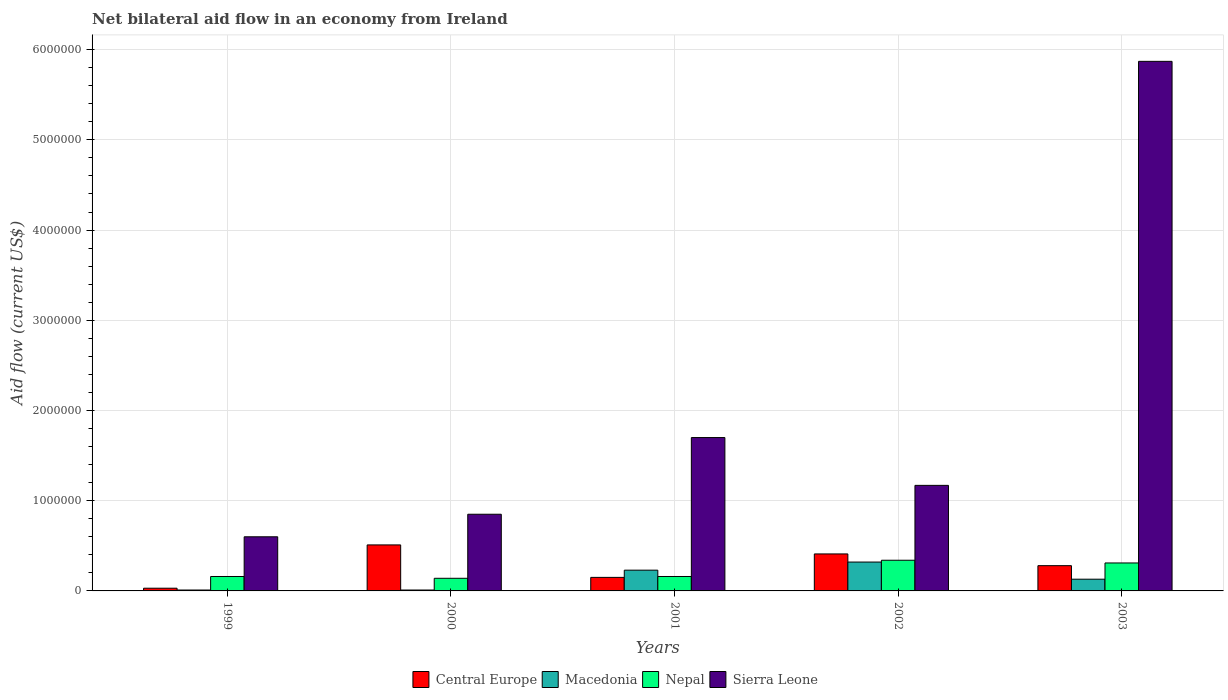How many different coloured bars are there?
Keep it short and to the point. 4. How many groups of bars are there?
Make the answer very short. 5. Are the number of bars per tick equal to the number of legend labels?
Your response must be concise. Yes. How many bars are there on the 1st tick from the left?
Give a very brief answer. 4. What is the label of the 4th group of bars from the left?
Offer a very short reply. 2002. What is the net bilateral aid flow in Central Europe in 1999?
Your answer should be very brief. 3.00e+04. Across all years, what is the maximum net bilateral aid flow in Macedonia?
Your answer should be compact. 3.20e+05. Across all years, what is the minimum net bilateral aid flow in Macedonia?
Your response must be concise. 10000. What is the total net bilateral aid flow in Sierra Leone in the graph?
Provide a succinct answer. 1.02e+07. What is the difference between the net bilateral aid flow in Sierra Leone in 2000 and the net bilateral aid flow in Macedonia in 1999?
Provide a short and direct response. 8.40e+05. What is the average net bilateral aid flow in Sierra Leone per year?
Give a very brief answer. 2.04e+06. In the year 1999, what is the difference between the net bilateral aid flow in Central Europe and net bilateral aid flow in Nepal?
Give a very brief answer. -1.30e+05. In how many years, is the net bilateral aid flow in Sierra Leone greater than 400000 US$?
Your response must be concise. 5. What is the ratio of the net bilateral aid flow in Central Europe in 2002 to that in 2003?
Your answer should be very brief. 1.46. What is the difference between the highest and the lowest net bilateral aid flow in Central Europe?
Your answer should be compact. 4.80e+05. Is the sum of the net bilateral aid flow in Macedonia in 2000 and 2002 greater than the maximum net bilateral aid flow in Central Europe across all years?
Offer a very short reply. No. What does the 4th bar from the left in 2000 represents?
Provide a short and direct response. Sierra Leone. What does the 1st bar from the right in 2001 represents?
Offer a terse response. Sierra Leone. How many bars are there?
Keep it short and to the point. 20. Are all the bars in the graph horizontal?
Your answer should be very brief. No. What is the difference between two consecutive major ticks on the Y-axis?
Your answer should be very brief. 1.00e+06. Does the graph contain any zero values?
Make the answer very short. No. Does the graph contain grids?
Keep it short and to the point. Yes. How many legend labels are there?
Provide a succinct answer. 4. How are the legend labels stacked?
Your answer should be very brief. Horizontal. What is the title of the graph?
Your answer should be compact. Net bilateral aid flow in an economy from Ireland. What is the Aid flow (current US$) in Macedonia in 1999?
Make the answer very short. 10000. What is the Aid flow (current US$) of Nepal in 1999?
Give a very brief answer. 1.60e+05. What is the Aid flow (current US$) of Sierra Leone in 1999?
Offer a terse response. 6.00e+05. What is the Aid flow (current US$) in Central Europe in 2000?
Offer a terse response. 5.10e+05. What is the Aid flow (current US$) of Nepal in 2000?
Your response must be concise. 1.40e+05. What is the Aid flow (current US$) in Sierra Leone in 2000?
Offer a very short reply. 8.50e+05. What is the Aid flow (current US$) in Central Europe in 2001?
Ensure brevity in your answer.  1.50e+05. What is the Aid flow (current US$) of Macedonia in 2001?
Give a very brief answer. 2.30e+05. What is the Aid flow (current US$) of Sierra Leone in 2001?
Make the answer very short. 1.70e+06. What is the Aid flow (current US$) of Macedonia in 2002?
Your response must be concise. 3.20e+05. What is the Aid flow (current US$) of Nepal in 2002?
Make the answer very short. 3.40e+05. What is the Aid flow (current US$) of Sierra Leone in 2002?
Your response must be concise. 1.17e+06. What is the Aid flow (current US$) of Nepal in 2003?
Your answer should be very brief. 3.10e+05. What is the Aid flow (current US$) of Sierra Leone in 2003?
Provide a short and direct response. 5.87e+06. Across all years, what is the maximum Aid flow (current US$) in Central Europe?
Make the answer very short. 5.10e+05. Across all years, what is the maximum Aid flow (current US$) of Macedonia?
Make the answer very short. 3.20e+05. Across all years, what is the maximum Aid flow (current US$) of Nepal?
Provide a short and direct response. 3.40e+05. Across all years, what is the maximum Aid flow (current US$) in Sierra Leone?
Offer a very short reply. 5.87e+06. Across all years, what is the minimum Aid flow (current US$) of Central Europe?
Keep it short and to the point. 3.00e+04. Across all years, what is the minimum Aid flow (current US$) in Macedonia?
Your answer should be very brief. 10000. Across all years, what is the minimum Aid flow (current US$) of Nepal?
Your answer should be compact. 1.40e+05. Across all years, what is the minimum Aid flow (current US$) of Sierra Leone?
Make the answer very short. 6.00e+05. What is the total Aid flow (current US$) of Central Europe in the graph?
Your answer should be very brief. 1.38e+06. What is the total Aid flow (current US$) of Nepal in the graph?
Give a very brief answer. 1.11e+06. What is the total Aid flow (current US$) of Sierra Leone in the graph?
Make the answer very short. 1.02e+07. What is the difference between the Aid flow (current US$) of Central Europe in 1999 and that in 2000?
Keep it short and to the point. -4.80e+05. What is the difference between the Aid flow (current US$) of Nepal in 1999 and that in 2000?
Make the answer very short. 2.00e+04. What is the difference between the Aid flow (current US$) of Sierra Leone in 1999 and that in 2000?
Offer a terse response. -2.50e+05. What is the difference between the Aid flow (current US$) of Sierra Leone in 1999 and that in 2001?
Provide a short and direct response. -1.10e+06. What is the difference between the Aid flow (current US$) of Central Europe in 1999 and that in 2002?
Ensure brevity in your answer.  -3.80e+05. What is the difference between the Aid flow (current US$) of Macedonia in 1999 and that in 2002?
Keep it short and to the point. -3.10e+05. What is the difference between the Aid flow (current US$) in Sierra Leone in 1999 and that in 2002?
Offer a very short reply. -5.70e+05. What is the difference between the Aid flow (current US$) of Central Europe in 1999 and that in 2003?
Provide a short and direct response. -2.50e+05. What is the difference between the Aid flow (current US$) in Macedonia in 1999 and that in 2003?
Your answer should be very brief. -1.20e+05. What is the difference between the Aid flow (current US$) of Sierra Leone in 1999 and that in 2003?
Provide a short and direct response. -5.27e+06. What is the difference between the Aid flow (current US$) in Central Europe in 2000 and that in 2001?
Offer a terse response. 3.60e+05. What is the difference between the Aid flow (current US$) in Macedonia in 2000 and that in 2001?
Ensure brevity in your answer.  -2.20e+05. What is the difference between the Aid flow (current US$) in Nepal in 2000 and that in 2001?
Your response must be concise. -2.00e+04. What is the difference between the Aid flow (current US$) of Sierra Leone in 2000 and that in 2001?
Provide a succinct answer. -8.50e+05. What is the difference between the Aid flow (current US$) in Central Europe in 2000 and that in 2002?
Ensure brevity in your answer.  1.00e+05. What is the difference between the Aid flow (current US$) of Macedonia in 2000 and that in 2002?
Offer a very short reply. -3.10e+05. What is the difference between the Aid flow (current US$) in Sierra Leone in 2000 and that in 2002?
Ensure brevity in your answer.  -3.20e+05. What is the difference between the Aid flow (current US$) of Central Europe in 2000 and that in 2003?
Provide a short and direct response. 2.30e+05. What is the difference between the Aid flow (current US$) in Nepal in 2000 and that in 2003?
Give a very brief answer. -1.70e+05. What is the difference between the Aid flow (current US$) in Sierra Leone in 2000 and that in 2003?
Offer a terse response. -5.02e+06. What is the difference between the Aid flow (current US$) of Macedonia in 2001 and that in 2002?
Make the answer very short. -9.00e+04. What is the difference between the Aid flow (current US$) in Nepal in 2001 and that in 2002?
Offer a very short reply. -1.80e+05. What is the difference between the Aid flow (current US$) of Sierra Leone in 2001 and that in 2002?
Give a very brief answer. 5.30e+05. What is the difference between the Aid flow (current US$) of Central Europe in 2001 and that in 2003?
Your answer should be very brief. -1.30e+05. What is the difference between the Aid flow (current US$) of Sierra Leone in 2001 and that in 2003?
Make the answer very short. -4.17e+06. What is the difference between the Aid flow (current US$) of Central Europe in 2002 and that in 2003?
Your answer should be very brief. 1.30e+05. What is the difference between the Aid flow (current US$) of Nepal in 2002 and that in 2003?
Your answer should be compact. 3.00e+04. What is the difference between the Aid flow (current US$) in Sierra Leone in 2002 and that in 2003?
Offer a very short reply. -4.70e+06. What is the difference between the Aid flow (current US$) of Central Europe in 1999 and the Aid flow (current US$) of Macedonia in 2000?
Keep it short and to the point. 2.00e+04. What is the difference between the Aid flow (current US$) of Central Europe in 1999 and the Aid flow (current US$) of Sierra Leone in 2000?
Give a very brief answer. -8.20e+05. What is the difference between the Aid flow (current US$) of Macedonia in 1999 and the Aid flow (current US$) of Nepal in 2000?
Provide a succinct answer. -1.30e+05. What is the difference between the Aid flow (current US$) in Macedonia in 1999 and the Aid flow (current US$) in Sierra Leone in 2000?
Your response must be concise. -8.40e+05. What is the difference between the Aid flow (current US$) of Nepal in 1999 and the Aid flow (current US$) of Sierra Leone in 2000?
Your answer should be very brief. -6.90e+05. What is the difference between the Aid flow (current US$) in Central Europe in 1999 and the Aid flow (current US$) in Nepal in 2001?
Your answer should be compact. -1.30e+05. What is the difference between the Aid flow (current US$) in Central Europe in 1999 and the Aid flow (current US$) in Sierra Leone in 2001?
Offer a very short reply. -1.67e+06. What is the difference between the Aid flow (current US$) in Macedonia in 1999 and the Aid flow (current US$) in Sierra Leone in 2001?
Your answer should be compact. -1.69e+06. What is the difference between the Aid flow (current US$) in Nepal in 1999 and the Aid flow (current US$) in Sierra Leone in 2001?
Give a very brief answer. -1.54e+06. What is the difference between the Aid flow (current US$) in Central Europe in 1999 and the Aid flow (current US$) in Nepal in 2002?
Give a very brief answer. -3.10e+05. What is the difference between the Aid flow (current US$) in Central Europe in 1999 and the Aid flow (current US$) in Sierra Leone in 2002?
Your response must be concise. -1.14e+06. What is the difference between the Aid flow (current US$) in Macedonia in 1999 and the Aid flow (current US$) in Nepal in 2002?
Keep it short and to the point. -3.30e+05. What is the difference between the Aid flow (current US$) of Macedonia in 1999 and the Aid flow (current US$) of Sierra Leone in 2002?
Keep it short and to the point. -1.16e+06. What is the difference between the Aid flow (current US$) of Nepal in 1999 and the Aid flow (current US$) of Sierra Leone in 2002?
Your answer should be compact. -1.01e+06. What is the difference between the Aid flow (current US$) in Central Europe in 1999 and the Aid flow (current US$) in Nepal in 2003?
Ensure brevity in your answer.  -2.80e+05. What is the difference between the Aid flow (current US$) in Central Europe in 1999 and the Aid flow (current US$) in Sierra Leone in 2003?
Make the answer very short. -5.84e+06. What is the difference between the Aid flow (current US$) in Macedonia in 1999 and the Aid flow (current US$) in Nepal in 2003?
Ensure brevity in your answer.  -3.00e+05. What is the difference between the Aid flow (current US$) in Macedonia in 1999 and the Aid flow (current US$) in Sierra Leone in 2003?
Ensure brevity in your answer.  -5.86e+06. What is the difference between the Aid flow (current US$) in Nepal in 1999 and the Aid flow (current US$) in Sierra Leone in 2003?
Offer a terse response. -5.71e+06. What is the difference between the Aid flow (current US$) in Central Europe in 2000 and the Aid flow (current US$) in Macedonia in 2001?
Your answer should be compact. 2.80e+05. What is the difference between the Aid flow (current US$) in Central Europe in 2000 and the Aid flow (current US$) in Sierra Leone in 2001?
Your answer should be compact. -1.19e+06. What is the difference between the Aid flow (current US$) of Macedonia in 2000 and the Aid flow (current US$) of Sierra Leone in 2001?
Provide a succinct answer. -1.69e+06. What is the difference between the Aid flow (current US$) in Nepal in 2000 and the Aid flow (current US$) in Sierra Leone in 2001?
Give a very brief answer. -1.56e+06. What is the difference between the Aid flow (current US$) of Central Europe in 2000 and the Aid flow (current US$) of Nepal in 2002?
Ensure brevity in your answer.  1.70e+05. What is the difference between the Aid flow (current US$) in Central Europe in 2000 and the Aid flow (current US$) in Sierra Leone in 2002?
Keep it short and to the point. -6.60e+05. What is the difference between the Aid flow (current US$) of Macedonia in 2000 and the Aid flow (current US$) of Nepal in 2002?
Give a very brief answer. -3.30e+05. What is the difference between the Aid flow (current US$) of Macedonia in 2000 and the Aid flow (current US$) of Sierra Leone in 2002?
Ensure brevity in your answer.  -1.16e+06. What is the difference between the Aid flow (current US$) in Nepal in 2000 and the Aid flow (current US$) in Sierra Leone in 2002?
Provide a short and direct response. -1.03e+06. What is the difference between the Aid flow (current US$) in Central Europe in 2000 and the Aid flow (current US$) in Macedonia in 2003?
Offer a very short reply. 3.80e+05. What is the difference between the Aid flow (current US$) in Central Europe in 2000 and the Aid flow (current US$) in Nepal in 2003?
Offer a terse response. 2.00e+05. What is the difference between the Aid flow (current US$) in Central Europe in 2000 and the Aid flow (current US$) in Sierra Leone in 2003?
Offer a terse response. -5.36e+06. What is the difference between the Aid flow (current US$) in Macedonia in 2000 and the Aid flow (current US$) in Sierra Leone in 2003?
Provide a short and direct response. -5.86e+06. What is the difference between the Aid flow (current US$) in Nepal in 2000 and the Aid flow (current US$) in Sierra Leone in 2003?
Give a very brief answer. -5.73e+06. What is the difference between the Aid flow (current US$) in Central Europe in 2001 and the Aid flow (current US$) in Sierra Leone in 2002?
Your response must be concise. -1.02e+06. What is the difference between the Aid flow (current US$) in Macedonia in 2001 and the Aid flow (current US$) in Nepal in 2002?
Provide a short and direct response. -1.10e+05. What is the difference between the Aid flow (current US$) in Macedonia in 2001 and the Aid flow (current US$) in Sierra Leone in 2002?
Your answer should be very brief. -9.40e+05. What is the difference between the Aid flow (current US$) of Nepal in 2001 and the Aid flow (current US$) of Sierra Leone in 2002?
Make the answer very short. -1.01e+06. What is the difference between the Aid flow (current US$) in Central Europe in 2001 and the Aid flow (current US$) in Nepal in 2003?
Provide a succinct answer. -1.60e+05. What is the difference between the Aid flow (current US$) in Central Europe in 2001 and the Aid flow (current US$) in Sierra Leone in 2003?
Your response must be concise. -5.72e+06. What is the difference between the Aid flow (current US$) of Macedonia in 2001 and the Aid flow (current US$) of Sierra Leone in 2003?
Keep it short and to the point. -5.64e+06. What is the difference between the Aid flow (current US$) in Nepal in 2001 and the Aid flow (current US$) in Sierra Leone in 2003?
Provide a short and direct response. -5.71e+06. What is the difference between the Aid flow (current US$) in Central Europe in 2002 and the Aid flow (current US$) in Nepal in 2003?
Your answer should be very brief. 1.00e+05. What is the difference between the Aid flow (current US$) in Central Europe in 2002 and the Aid flow (current US$) in Sierra Leone in 2003?
Your answer should be very brief. -5.46e+06. What is the difference between the Aid flow (current US$) in Macedonia in 2002 and the Aid flow (current US$) in Nepal in 2003?
Keep it short and to the point. 10000. What is the difference between the Aid flow (current US$) of Macedonia in 2002 and the Aid flow (current US$) of Sierra Leone in 2003?
Ensure brevity in your answer.  -5.55e+06. What is the difference between the Aid flow (current US$) of Nepal in 2002 and the Aid flow (current US$) of Sierra Leone in 2003?
Provide a succinct answer. -5.53e+06. What is the average Aid flow (current US$) of Central Europe per year?
Your response must be concise. 2.76e+05. What is the average Aid flow (current US$) in Macedonia per year?
Ensure brevity in your answer.  1.40e+05. What is the average Aid flow (current US$) in Nepal per year?
Ensure brevity in your answer.  2.22e+05. What is the average Aid flow (current US$) in Sierra Leone per year?
Provide a short and direct response. 2.04e+06. In the year 1999, what is the difference between the Aid flow (current US$) in Central Europe and Aid flow (current US$) in Sierra Leone?
Give a very brief answer. -5.70e+05. In the year 1999, what is the difference between the Aid flow (current US$) of Macedonia and Aid flow (current US$) of Nepal?
Keep it short and to the point. -1.50e+05. In the year 1999, what is the difference between the Aid flow (current US$) in Macedonia and Aid flow (current US$) in Sierra Leone?
Ensure brevity in your answer.  -5.90e+05. In the year 1999, what is the difference between the Aid flow (current US$) in Nepal and Aid flow (current US$) in Sierra Leone?
Make the answer very short. -4.40e+05. In the year 2000, what is the difference between the Aid flow (current US$) of Central Europe and Aid flow (current US$) of Macedonia?
Offer a very short reply. 5.00e+05. In the year 2000, what is the difference between the Aid flow (current US$) of Central Europe and Aid flow (current US$) of Sierra Leone?
Provide a succinct answer. -3.40e+05. In the year 2000, what is the difference between the Aid flow (current US$) in Macedonia and Aid flow (current US$) in Sierra Leone?
Make the answer very short. -8.40e+05. In the year 2000, what is the difference between the Aid flow (current US$) in Nepal and Aid flow (current US$) in Sierra Leone?
Provide a succinct answer. -7.10e+05. In the year 2001, what is the difference between the Aid flow (current US$) in Central Europe and Aid flow (current US$) in Nepal?
Keep it short and to the point. -10000. In the year 2001, what is the difference between the Aid flow (current US$) of Central Europe and Aid flow (current US$) of Sierra Leone?
Offer a terse response. -1.55e+06. In the year 2001, what is the difference between the Aid flow (current US$) in Macedonia and Aid flow (current US$) in Sierra Leone?
Provide a succinct answer. -1.47e+06. In the year 2001, what is the difference between the Aid flow (current US$) of Nepal and Aid flow (current US$) of Sierra Leone?
Provide a short and direct response. -1.54e+06. In the year 2002, what is the difference between the Aid flow (current US$) of Central Europe and Aid flow (current US$) of Macedonia?
Your response must be concise. 9.00e+04. In the year 2002, what is the difference between the Aid flow (current US$) in Central Europe and Aid flow (current US$) in Sierra Leone?
Offer a very short reply. -7.60e+05. In the year 2002, what is the difference between the Aid flow (current US$) in Macedonia and Aid flow (current US$) in Nepal?
Provide a short and direct response. -2.00e+04. In the year 2002, what is the difference between the Aid flow (current US$) in Macedonia and Aid flow (current US$) in Sierra Leone?
Your response must be concise. -8.50e+05. In the year 2002, what is the difference between the Aid flow (current US$) in Nepal and Aid flow (current US$) in Sierra Leone?
Offer a very short reply. -8.30e+05. In the year 2003, what is the difference between the Aid flow (current US$) in Central Europe and Aid flow (current US$) in Macedonia?
Your response must be concise. 1.50e+05. In the year 2003, what is the difference between the Aid flow (current US$) in Central Europe and Aid flow (current US$) in Nepal?
Offer a terse response. -3.00e+04. In the year 2003, what is the difference between the Aid flow (current US$) in Central Europe and Aid flow (current US$) in Sierra Leone?
Provide a short and direct response. -5.59e+06. In the year 2003, what is the difference between the Aid flow (current US$) in Macedonia and Aid flow (current US$) in Nepal?
Your answer should be compact. -1.80e+05. In the year 2003, what is the difference between the Aid flow (current US$) of Macedonia and Aid flow (current US$) of Sierra Leone?
Keep it short and to the point. -5.74e+06. In the year 2003, what is the difference between the Aid flow (current US$) in Nepal and Aid flow (current US$) in Sierra Leone?
Your answer should be very brief. -5.56e+06. What is the ratio of the Aid flow (current US$) of Central Europe in 1999 to that in 2000?
Make the answer very short. 0.06. What is the ratio of the Aid flow (current US$) of Macedonia in 1999 to that in 2000?
Provide a succinct answer. 1. What is the ratio of the Aid flow (current US$) of Sierra Leone in 1999 to that in 2000?
Offer a terse response. 0.71. What is the ratio of the Aid flow (current US$) in Macedonia in 1999 to that in 2001?
Your answer should be very brief. 0.04. What is the ratio of the Aid flow (current US$) in Sierra Leone in 1999 to that in 2001?
Make the answer very short. 0.35. What is the ratio of the Aid flow (current US$) of Central Europe in 1999 to that in 2002?
Your answer should be compact. 0.07. What is the ratio of the Aid flow (current US$) of Macedonia in 1999 to that in 2002?
Keep it short and to the point. 0.03. What is the ratio of the Aid flow (current US$) in Nepal in 1999 to that in 2002?
Your answer should be very brief. 0.47. What is the ratio of the Aid flow (current US$) in Sierra Leone in 1999 to that in 2002?
Ensure brevity in your answer.  0.51. What is the ratio of the Aid flow (current US$) in Central Europe in 1999 to that in 2003?
Offer a terse response. 0.11. What is the ratio of the Aid flow (current US$) of Macedonia in 1999 to that in 2003?
Provide a short and direct response. 0.08. What is the ratio of the Aid flow (current US$) in Nepal in 1999 to that in 2003?
Provide a succinct answer. 0.52. What is the ratio of the Aid flow (current US$) of Sierra Leone in 1999 to that in 2003?
Your answer should be very brief. 0.1. What is the ratio of the Aid flow (current US$) of Central Europe in 2000 to that in 2001?
Give a very brief answer. 3.4. What is the ratio of the Aid flow (current US$) of Macedonia in 2000 to that in 2001?
Offer a very short reply. 0.04. What is the ratio of the Aid flow (current US$) in Central Europe in 2000 to that in 2002?
Your answer should be very brief. 1.24. What is the ratio of the Aid flow (current US$) of Macedonia in 2000 to that in 2002?
Your answer should be very brief. 0.03. What is the ratio of the Aid flow (current US$) of Nepal in 2000 to that in 2002?
Offer a very short reply. 0.41. What is the ratio of the Aid flow (current US$) in Sierra Leone in 2000 to that in 2002?
Keep it short and to the point. 0.73. What is the ratio of the Aid flow (current US$) in Central Europe in 2000 to that in 2003?
Your answer should be compact. 1.82. What is the ratio of the Aid flow (current US$) of Macedonia in 2000 to that in 2003?
Your answer should be very brief. 0.08. What is the ratio of the Aid flow (current US$) of Nepal in 2000 to that in 2003?
Provide a succinct answer. 0.45. What is the ratio of the Aid flow (current US$) in Sierra Leone in 2000 to that in 2003?
Your response must be concise. 0.14. What is the ratio of the Aid flow (current US$) of Central Europe in 2001 to that in 2002?
Offer a very short reply. 0.37. What is the ratio of the Aid flow (current US$) of Macedonia in 2001 to that in 2002?
Ensure brevity in your answer.  0.72. What is the ratio of the Aid flow (current US$) of Nepal in 2001 to that in 2002?
Make the answer very short. 0.47. What is the ratio of the Aid flow (current US$) in Sierra Leone in 2001 to that in 2002?
Provide a short and direct response. 1.45. What is the ratio of the Aid flow (current US$) in Central Europe in 2001 to that in 2003?
Keep it short and to the point. 0.54. What is the ratio of the Aid flow (current US$) of Macedonia in 2001 to that in 2003?
Offer a terse response. 1.77. What is the ratio of the Aid flow (current US$) of Nepal in 2001 to that in 2003?
Offer a very short reply. 0.52. What is the ratio of the Aid flow (current US$) in Sierra Leone in 2001 to that in 2003?
Give a very brief answer. 0.29. What is the ratio of the Aid flow (current US$) of Central Europe in 2002 to that in 2003?
Ensure brevity in your answer.  1.46. What is the ratio of the Aid flow (current US$) in Macedonia in 2002 to that in 2003?
Give a very brief answer. 2.46. What is the ratio of the Aid flow (current US$) of Nepal in 2002 to that in 2003?
Provide a short and direct response. 1.1. What is the ratio of the Aid flow (current US$) in Sierra Leone in 2002 to that in 2003?
Keep it short and to the point. 0.2. What is the difference between the highest and the second highest Aid flow (current US$) in Central Europe?
Provide a succinct answer. 1.00e+05. What is the difference between the highest and the second highest Aid flow (current US$) in Macedonia?
Offer a terse response. 9.00e+04. What is the difference between the highest and the second highest Aid flow (current US$) of Sierra Leone?
Provide a succinct answer. 4.17e+06. What is the difference between the highest and the lowest Aid flow (current US$) in Central Europe?
Keep it short and to the point. 4.80e+05. What is the difference between the highest and the lowest Aid flow (current US$) in Nepal?
Your response must be concise. 2.00e+05. What is the difference between the highest and the lowest Aid flow (current US$) of Sierra Leone?
Offer a very short reply. 5.27e+06. 